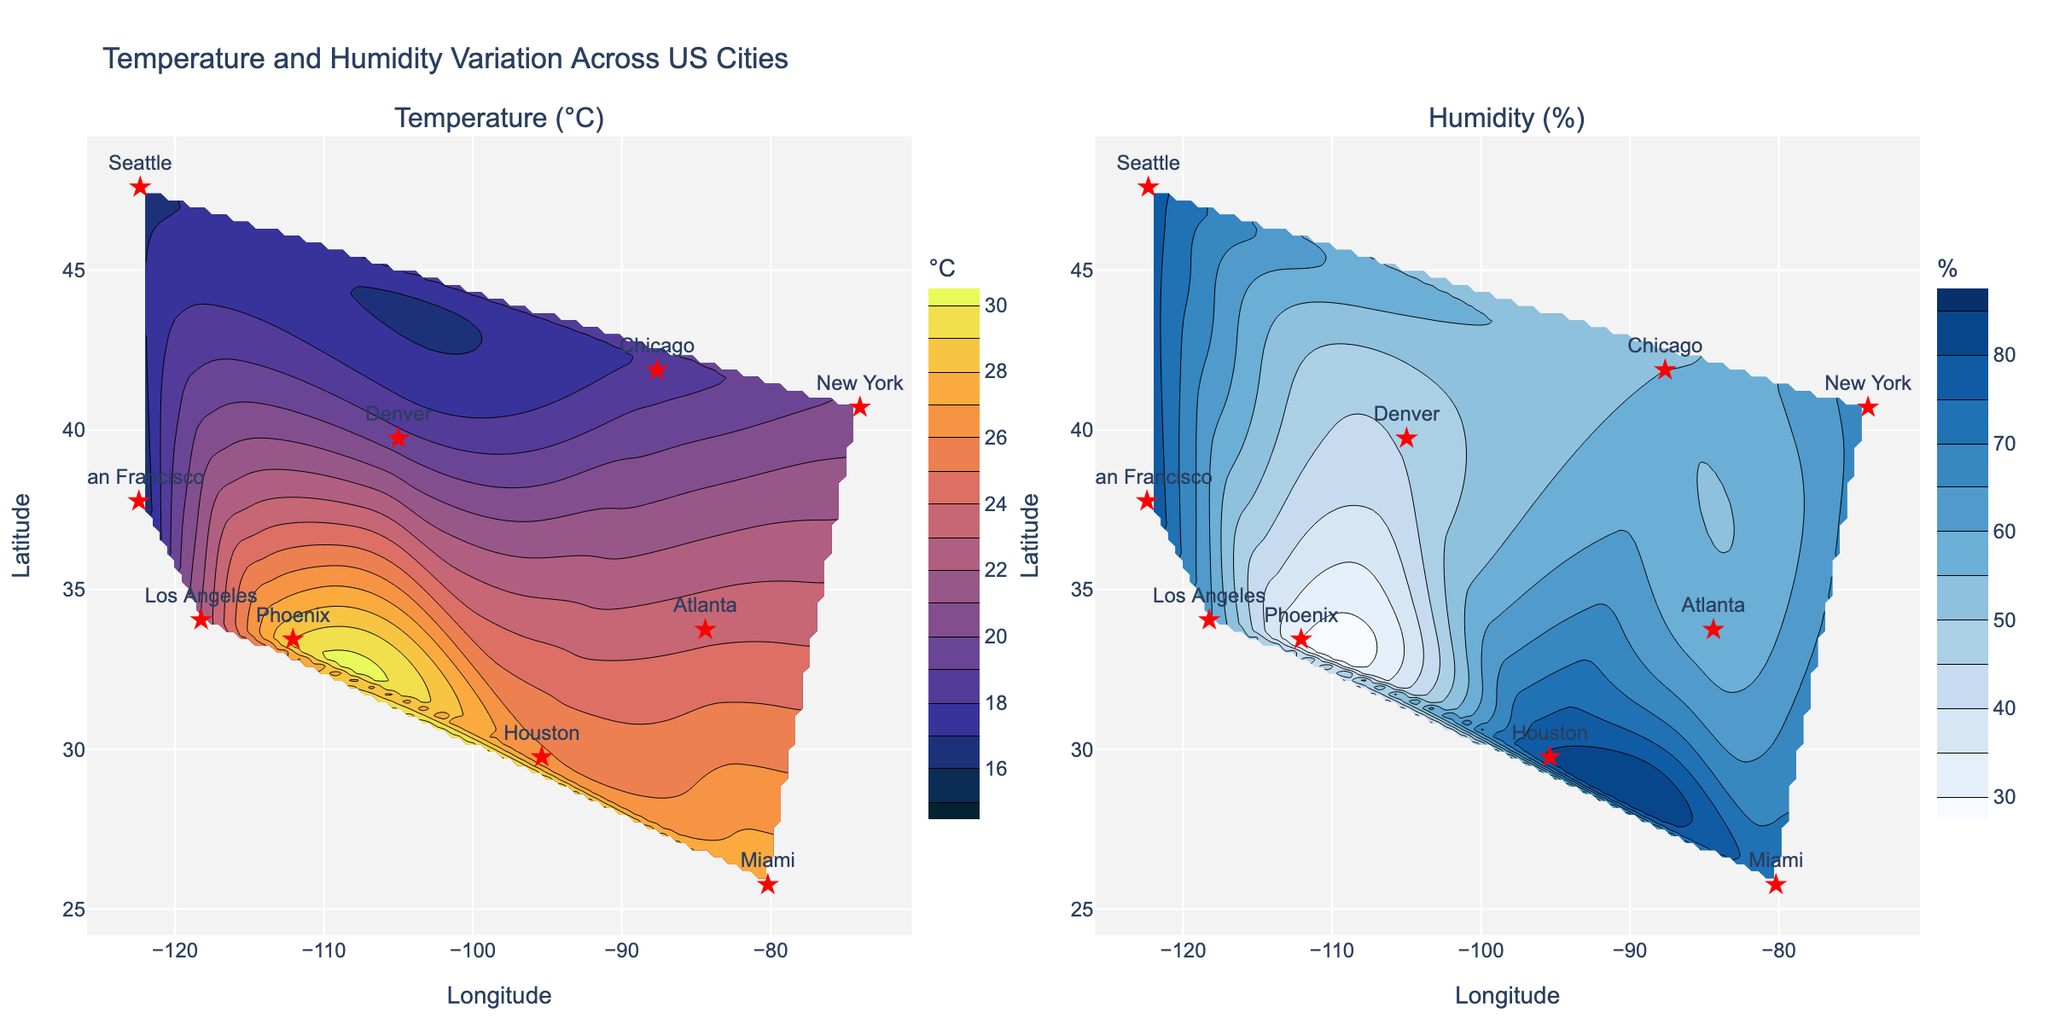What is the title of the figure? The title is displayed at the top of the figure. It reads "Temperature and Humidity Variation Across US Cities."
Answer: Temperature and Humidity Variation Across US Cities What are the units used for the Temperature and Humidity contours respectively? The units for Temperature are degrees Celsius (°C), and the units for Humidity are percent (%). This is indicated by the titles on the color bars for each contour plot.
Answer: °C, % Which city has the highest temperature according to the plot? The contour plot for Temperature shows city markers, and Phoenix appears in the region with the highest temperature values close to 29 degrees Celsius.
Answer: Phoenix Identify the city with the lowest humidity level. The contour plot for Humidity shows city markers, and Phoenix appears in the region with the lowest values around 30 percent humidity.
Answer: Phoenix Which city is represented by the star-shaped marker located at approximately 25.7617 latitude and -80.1918 longitude? The city markers on the plot are labeled, and the one at approximately 25.7617 latitude and -80.1918 longitude corresponds to Miami.
Answer: Miami Compare the humidity levels of San Francisco and Houston. Which city has higher humidity? By locating the star markers for both cities on the Humidity contour plot, we can observe that San Francisco shows a humidity level around 82%, while Houston shows a slightly lower humidity level of 81%.
Answer: San Francisco What is the temperature difference between Los Angeles and Denver based on the contour plot? The contour plots indicate the temperatures for Los Angeles and Denver as 22.1°C and 19.4°C, respectively. The difference is 22.1 - 19.4 = 2.7°C.
Answer: 2.7°C List the cities that fall within a temperature range of 15°C to 20°C. The temperature contour plot indicates that San Francisco (15.5°C), Chicago (18.3°C), and Seattle (16.7°C) fall within this range.
Answer: San Francisco, Chicago, Seattle What color scale is used for the humidity contour plot? The color scale used for the Humidity contour plot is primarily shades of blue, as indicated by the visual representation and the title of the color bar.
Answer: Blues Identify a region with high temperature but low humidity on the contour plots. The temperature contour plot shows a high temperature in the region around Phoenix (approximately 29°C), and the humidity contour plot indicates that this region has low humidity around 30%.
Answer: Phoenix area 